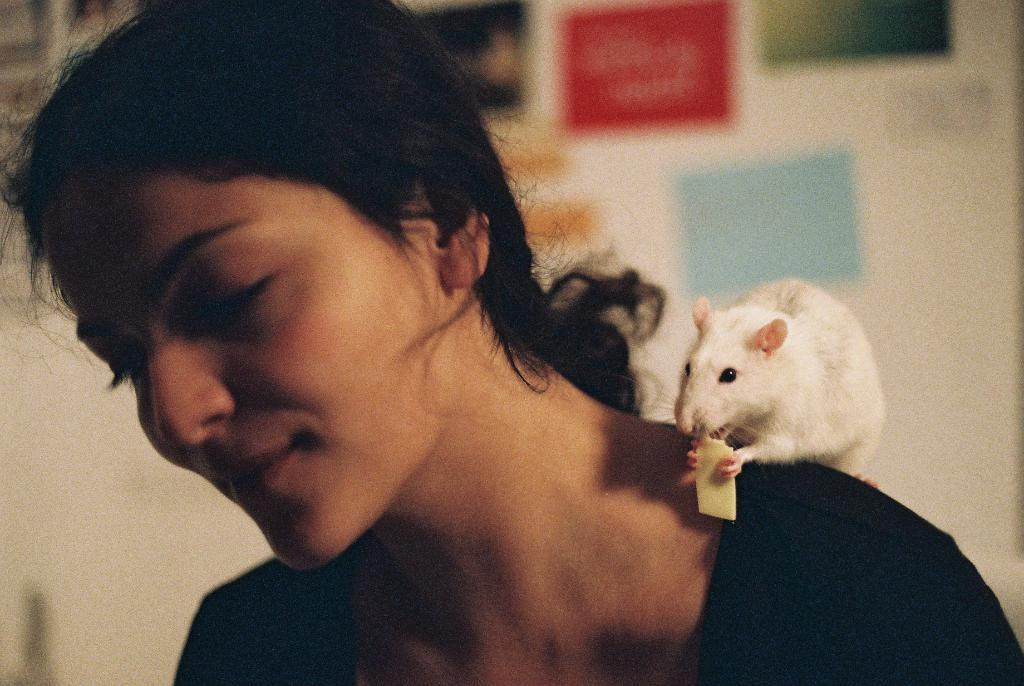What is the main subject of the image? There is a woman in the image. Can you describe any other living creature in the image? There is an animal in the image. Where is the animal positioned in relation to the woman? The animal is on the woman's shoulder. How many feet does the committee have in the image? There is no committee present in the image, and therefore no feet to count. 